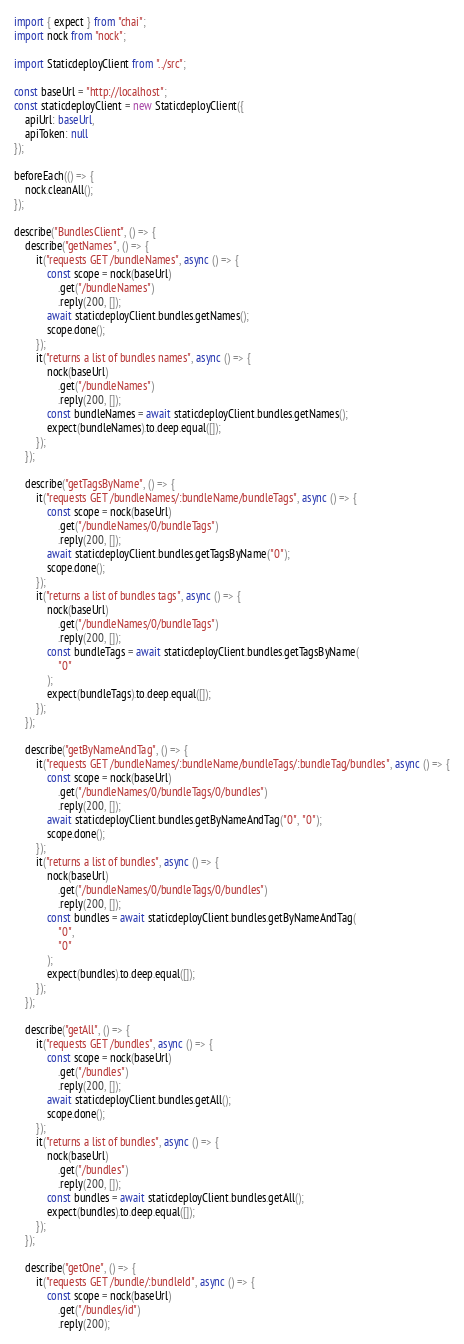Convert code to text. <code><loc_0><loc_0><loc_500><loc_500><_TypeScript_>import { expect } from "chai";
import nock from "nock";

import StaticdeployClient from "../src";

const baseUrl = "http://localhost";
const staticdeployClient = new StaticdeployClient({
    apiUrl: baseUrl,
    apiToken: null
});

beforeEach(() => {
    nock.cleanAll();
});

describe("BundlesClient", () => {
    describe("getNames", () => {
        it("requests GET /bundleNames", async () => {
            const scope = nock(baseUrl)
                .get("/bundleNames")
                .reply(200, []);
            await staticdeployClient.bundles.getNames();
            scope.done();
        });
        it("returns a list of bundles names", async () => {
            nock(baseUrl)
                .get("/bundleNames")
                .reply(200, []);
            const bundleNames = await staticdeployClient.bundles.getNames();
            expect(bundleNames).to.deep.equal([]);
        });
    });

    describe("getTagsByName", () => {
        it("requests GET /bundleNames/:bundleName/bundleTags", async () => {
            const scope = nock(baseUrl)
                .get("/bundleNames/0/bundleTags")
                .reply(200, []);
            await staticdeployClient.bundles.getTagsByName("0");
            scope.done();
        });
        it("returns a list of bundles tags", async () => {
            nock(baseUrl)
                .get("/bundleNames/0/bundleTags")
                .reply(200, []);
            const bundleTags = await staticdeployClient.bundles.getTagsByName(
                "0"
            );
            expect(bundleTags).to.deep.equal([]);
        });
    });

    describe("getByNameAndTag", () => {
        it("requests GET /bundleNames/:bundleName/bundleTags/:bundleTag/bundles", async () => {
            const scope = nock(baseUrl)
                .get("/bundleNames/0/bundleTags/0/bundles")
                .reply(200, []);
            await staticdeployClient.bundles.getByNameAndTag("0", "0");
            scope.done();
        });
        it("returns a list of bundles", async () => {
            nock(baseUrl)
                .get("/bundleNames/0/bundleTags/0/bundles")
                .reply(200, []);
            const bundles = await staticdeployClient.bundles.getByNameAndTag(
                "0",
                "0"
            );
            expect(bundles).to.deep.equal([]);
        });
    });

    describe("getAll", () => {
        it("requests GET /bundles", async () => {
            const scope = nock(baseUrl)
                .get("/bundles")
                .reply(200, []);
            await staticdeployClient.bundles.getAll();
            scope.done();
        });
        it("returns a list of bundles", async () => {
            nock(baseUrl)
                .get("/bundles")
                .reply(200, []);
            const bundles = await staticdeployClient.bundles.getAll();
            expect(bundles).to.deep.equal([]);
        });
    });

    describe("getOne", () => {
        it("requests GET /bundle/:bundleId", async () => {
            const scope = nock(baseUrl)
                .get("/bundles/id")
                .reply(200);</code> 